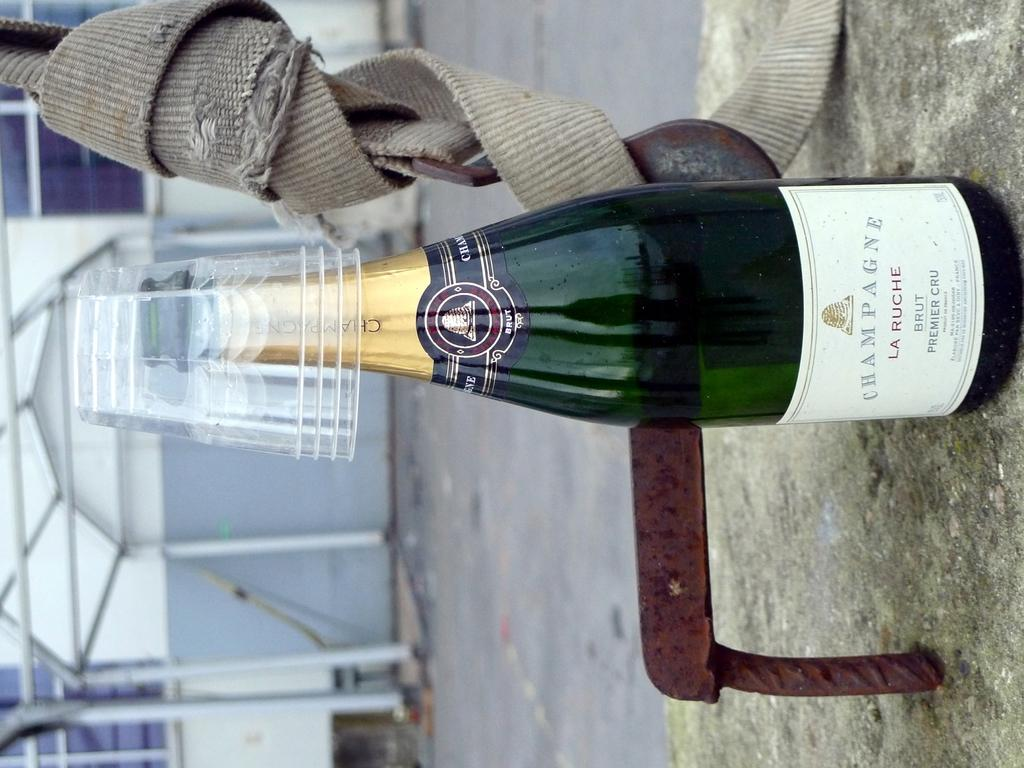What is located in the middle of the image? There is a bottle in the middle of the image. What is on the bottle? There are glasses on the bottle. What can be seen in the background of the image? There is a building behind the bottle. Can you see a knife cutting through the mist in the image? There is no knife or mist present in the image. 